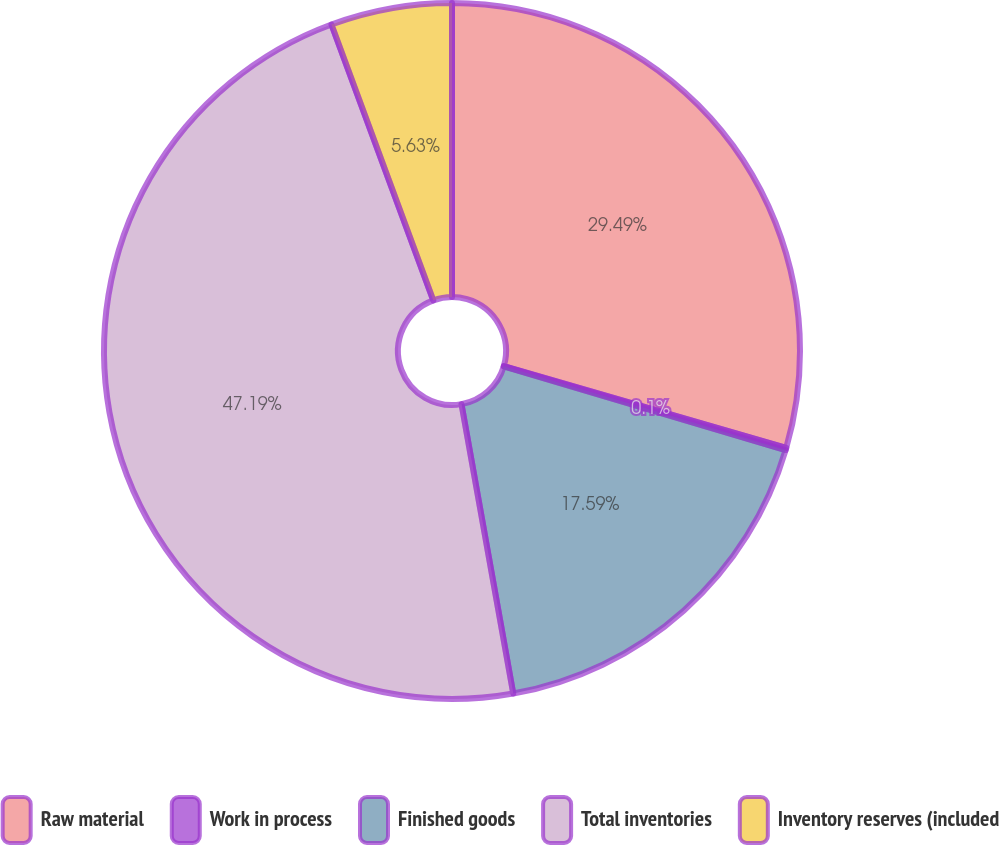Convert chart. <chart><loc_0><loc_0><loc_500><loc_500><pie_chart><fcel>Raw material<fcel>Work in process<fcel>Finished goods<fcel>Total inventories<fcel>Inventory reserves (included<nl><fcel>29.49%<fcel>0.1%<fcel>17.59%<fcel>47.18%<fcel>5.63%<nl></chart> 